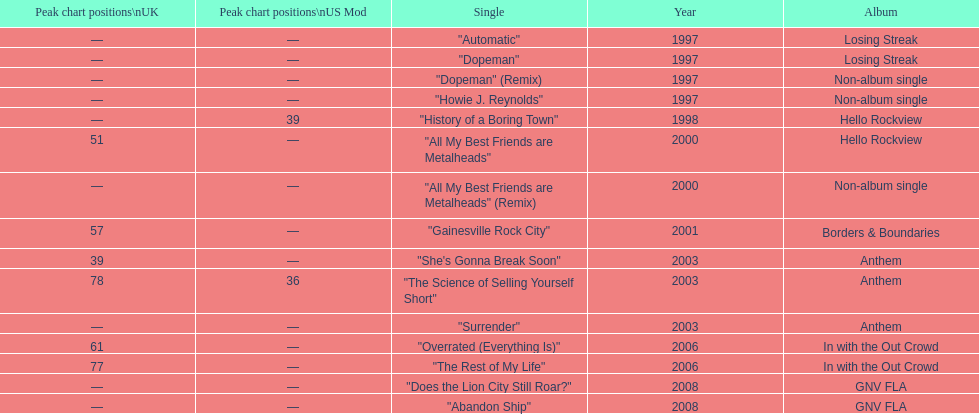Which single was released before "dopeman"? "Automatic". 